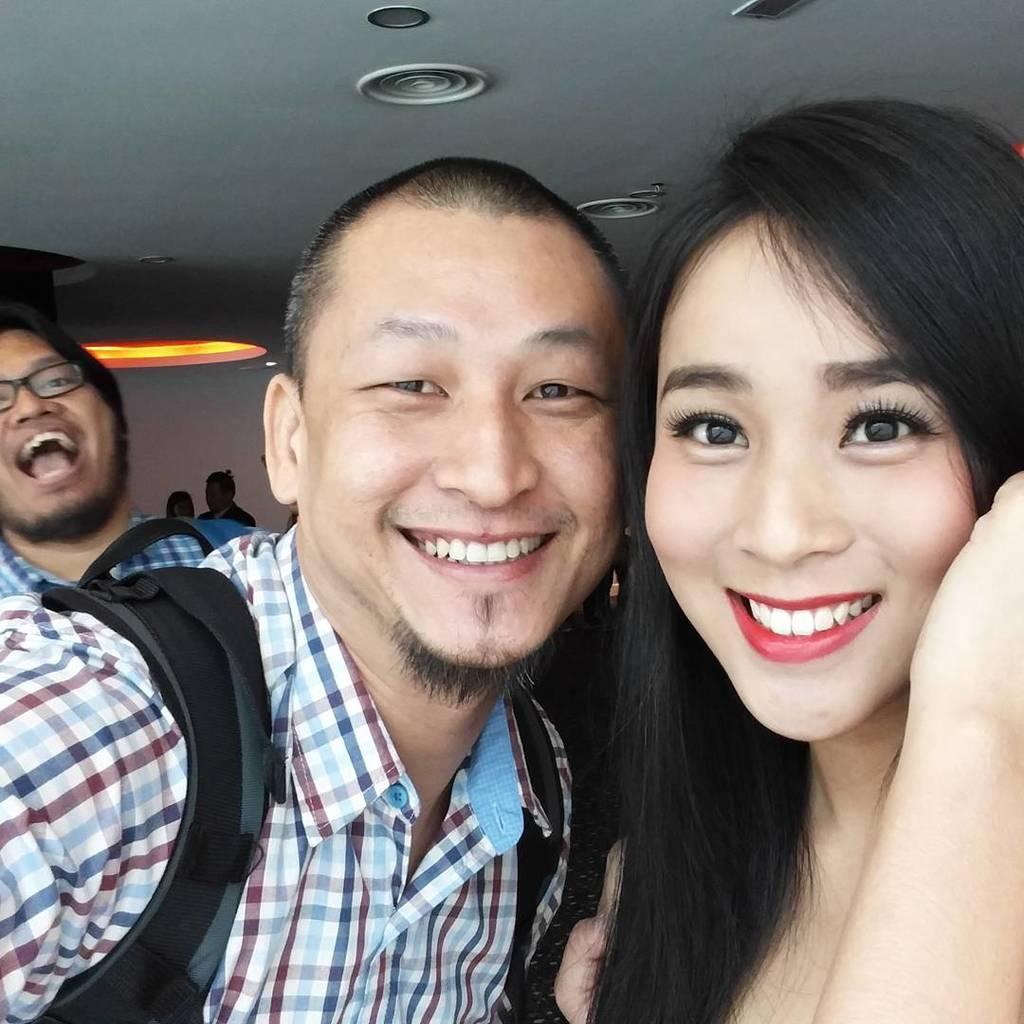Describe this image in one or two sentences. In this image in front there are two persons wearing a smile on their faces. Behind them there a few other people. On top of the image there are lights. In the background of the image there is a wall. 